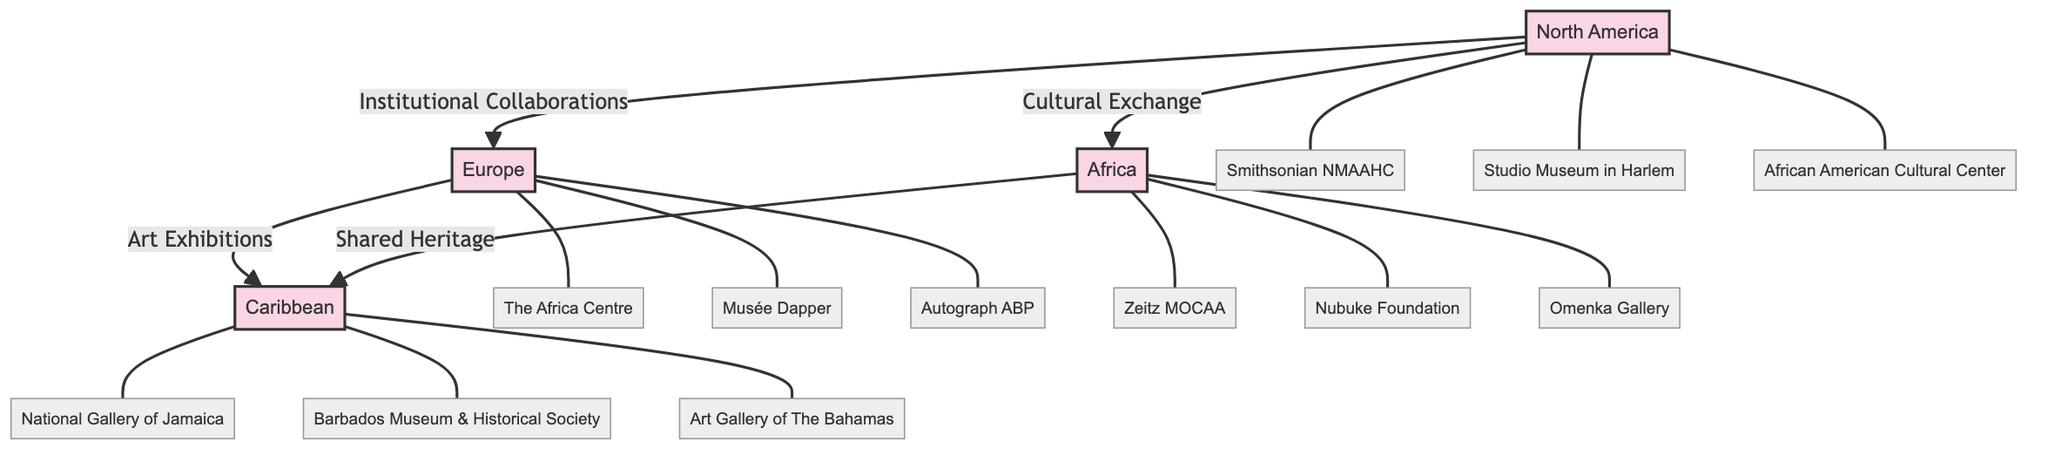What regions are highlighted in the diagram? The diagram highlights four regions: North America, Europe, Africa, and the Caribbean. These are listed as the main nodes in the diagram.
Answer: North America, Europe, Africa, Caribbean How many notable Black art galleries and museums are listed for North America? In North America, there are three notable galleries and museums listed: Smithsonian NMAAHC, Studio Museum in Harlem, and African American Cultural Center. This can be counted from the detail nodes branching from North America.
Answer: 3 Which region has the gallery "Zeitz MOCAA"? The gallery "Zeitz MOCAA" is located in Africa, as indicated by its connection to the Africa node in the diagram.
Answer: Africa What type of collaborations are indicated between North America and Europe? The diagram indicates "Institutional Collaborations" as the relationship between North America and Europe through a connecting edge.
Answer: Institutional Collaborations Name one art gallery in the Caribbean mentioned in the diagram. The National Gallery of Jamaica is one of the galleries listed in the Caribbean section of the diagram.
Answer: National Gallery of Jamaica Which two regions share the "Shared Heritage" relationship? The regions that share the "Shared Heritage" relationship are Africa and the Caribbean, as shown by the connecting edge between them.
Answer: Africa, Caribbean How many art galleries in total are represented in the diagram? To find the total count, add the number of galleries/museums listed: 3 from North America, 3 from Europe, 3 from Africa, and 3 from the Caribbean, which totals to 12 galleries/museums.
Answer: 12 What is the nature of the connection between Europe and the Caribbean? The connection between Europe and the Caribbean is represented as "Art Exhibitions," indicating a type of relationship focusing on showcasing art.
Answer: Art Exhibitions Which gallery represents the Caribbean cultural scene in the diagram? The "Barbados Museum & Historical Society" represents the Caribbean cultural scene among the listed galleries in the diagram.
Answer: Barbados Museum & Historical Society 